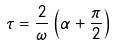<formula> <loc_0><loc_0><loc_500><loc_500>\tau = \frac { 2 } { \omega } \left ( \alpha + \frac { \pi } { 2 } \right )</formula> 